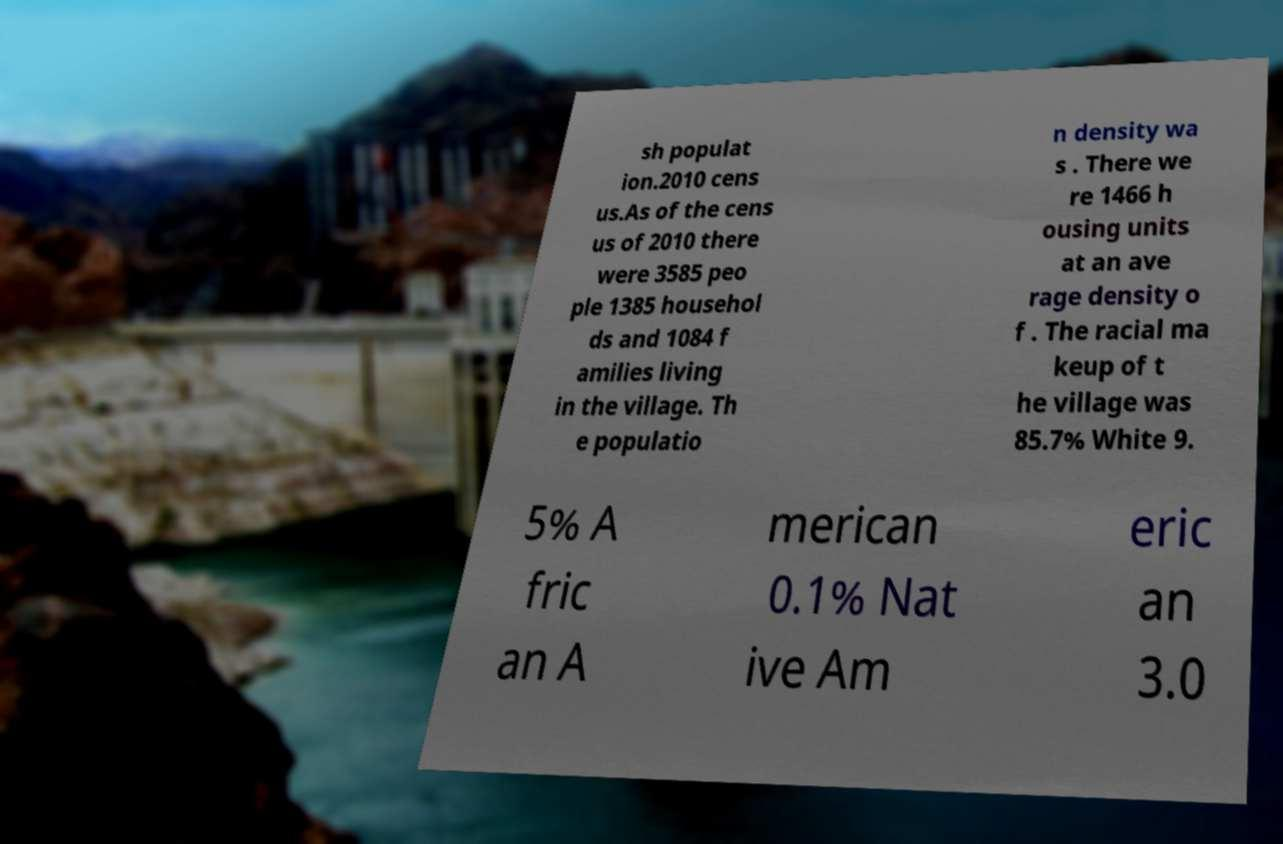Can you accurately transcribe the text from the provided image for me? sh populat ion.2010 cens us.As of the cens us of 2010 there were 3585 peo ple 1385 househol ds and 1084 f amilies living in the village. Th e populatio n density wa s . There we re 1466 h ousing units at an ave rage density o f . The racial ma keup of t he village was 85.7% White 9. 5% A fric an A merican 0.1% Nat ive Am eric an 3.0 